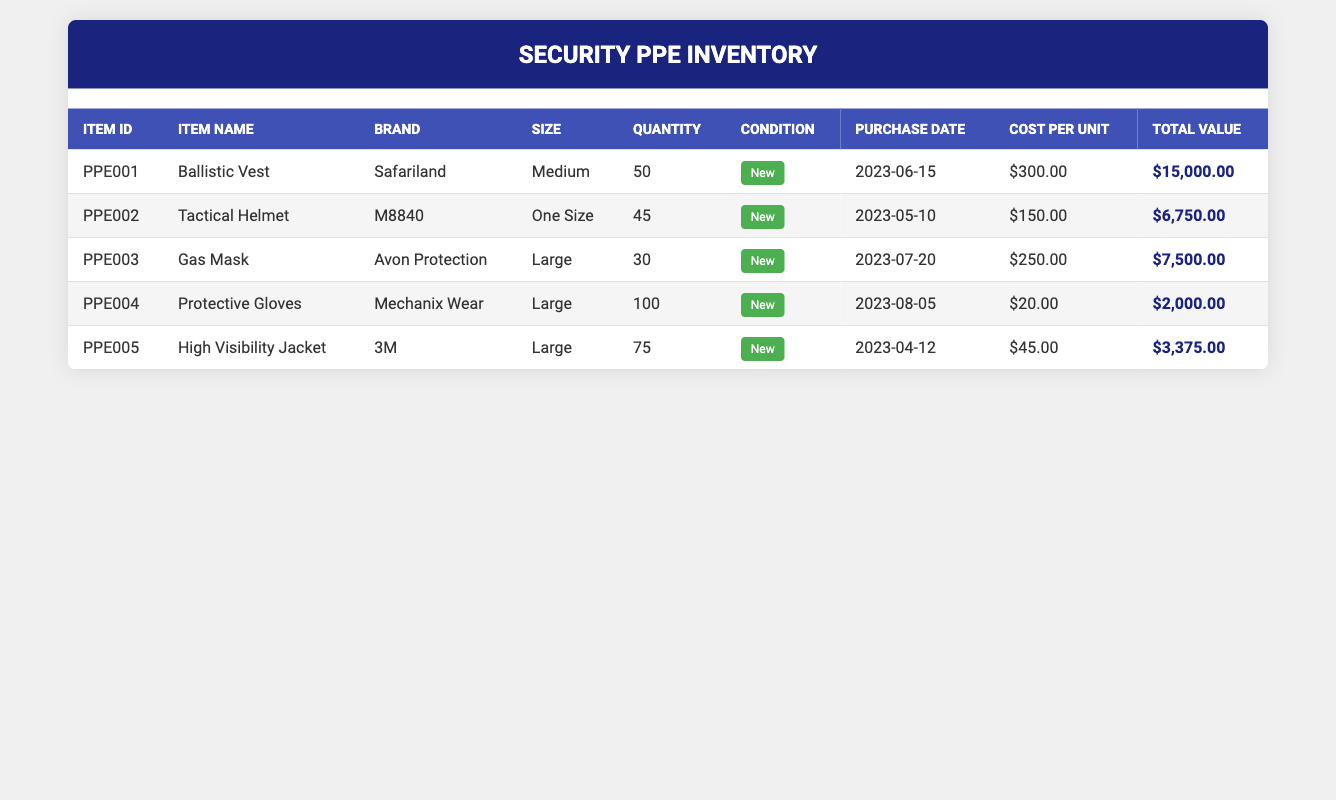What is the total quantity of Ballistic Vests in the inventory? The table shows that the quantity for the Ballistic Vest (ItemID: PPE001) is 50. Therefore, the total quantity of Ballistic Vests is directly taken from this value.
Answer: 50 How many Tactical Helmets do we have compared to Gas Masks? From the table, there are 45 Tactical Helmets (ItemID: PPE002) and 30 Gas Masks (ItemID: PPE003). Comparing the two, we find that there are more Tactical Helmets than Gas Masks by subtracting the quantity of Gas Masks from Tactical Helmets: 45 - 30 = 15.
Answer: 15 What is the total value of all Protective Gloves in the inventory? The table indicates that there are 100 Protective Gloves (ItemID: PPE004) with a cost per unit of $20. To find the total value, we multiply the quantity by the cost per unit: 100 x 20 = 2000.
Answer: 2000 Is the condition of all items in inventory marked as new? By reviewing the condition column, we see each item (Ballistic Vest, Tactical Helmet, Gas Mask, Protective Gloves, High Visibility Jacket) is marked as "New." Since all items are listed as new, the answer is yes.
Answer: Yes What is the average cost per unit of the PPE items in our inventory? The cost per unit for the items are $300 (Ballistic Vest), $150 (Tactical Helmet), $250 (Gas Mask), $20 (Protective Gloves), and $45 (High Visibility Jacket). Summing these values gives 300 + 150 + 250 + 20 + 45 = 765. Since there are 5 items, we divide the total by 5: 765 / 5 = 153.
Answer: 153 How much more expensive is the Gas Mask compared to the Tactical Helmet? The cost per unit for the Gas Mask is $250 and for the Tactical Helmet, it's $150. To find how much more expensive the Gas Mask is, we subtract the cost of the Tactical Helmet from that of the Gas Mask: 250 - 150 = 100.
Answer: 100 Which item has the highest total value in the inventory? By looking at the total values in the table, the Ballistic Vest has a total value of $15,000, Tactical Helmet $6,750, Gas Mask $7,500, Protective Gloves $2,000, and High Visibility Jacket $3,375. The highest total value is therefore for the Ballistic Vest at $15,000.
Answer: Ballistic Vest What is the total quantity of all items in the inventory? To find the total quantity, we add the quantities of all items: 50 (Ballistic Vest) + 45 (Tactical Helmet) + 30 (Gas Mask) + 100 (Protective Gloves) + 75 (High Visibility Jacket) = 300.
Answer: 300 Is the High Visibility Jacket the only item that comes in Large size? The High Visibility Jacket is indeed listed as Large, but the Gas Mask, Protective Gloves, and Tactical Helmet also have sizes of Large or One Size that can fit large sizes. Since multiple items are available in Large, the statement is false.
Answer: No 